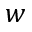<formula> <loc_0><loc_0><loc_500><loc_500>w</formula> 